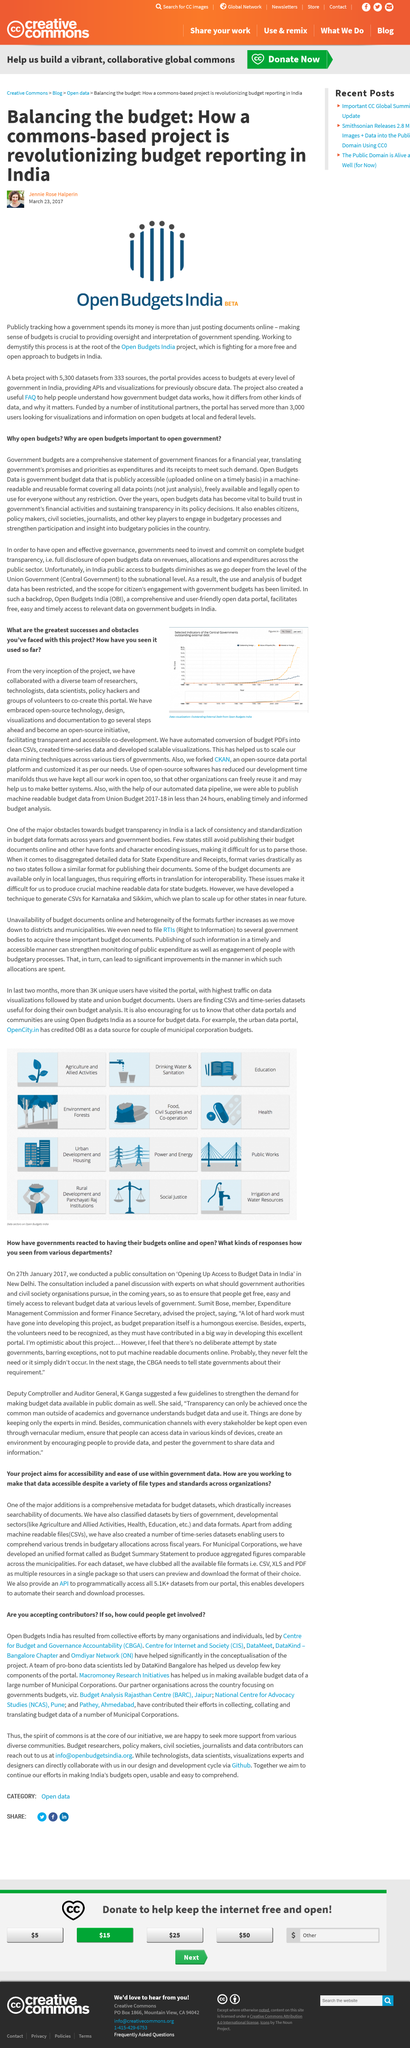List a handful of essential elements in this visual. We will be involved in the process of collecting, collating, and translating budget data. The project is named Open Budgets India, which is named after its purpose. Macromoney Research Initiatives is the entity responsible for providing access to budget data. Open Budgets India is currently accepting contributors. The project is currently assisting in India. 